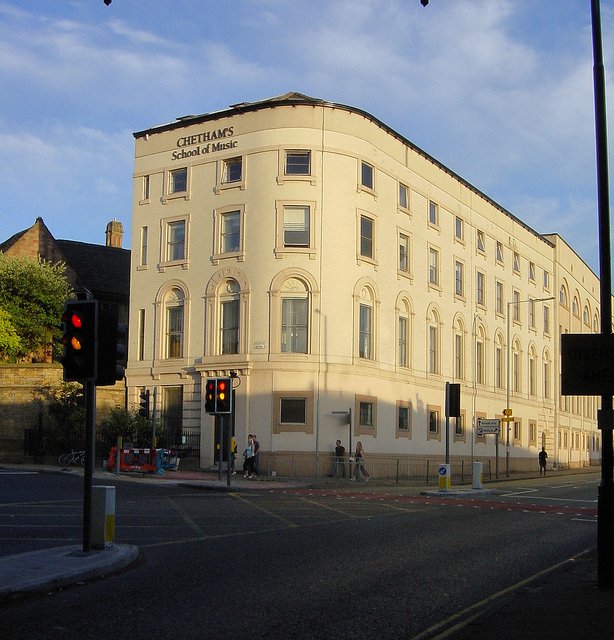Extract all visible text content from this image. CHETHAM'S School of Music 